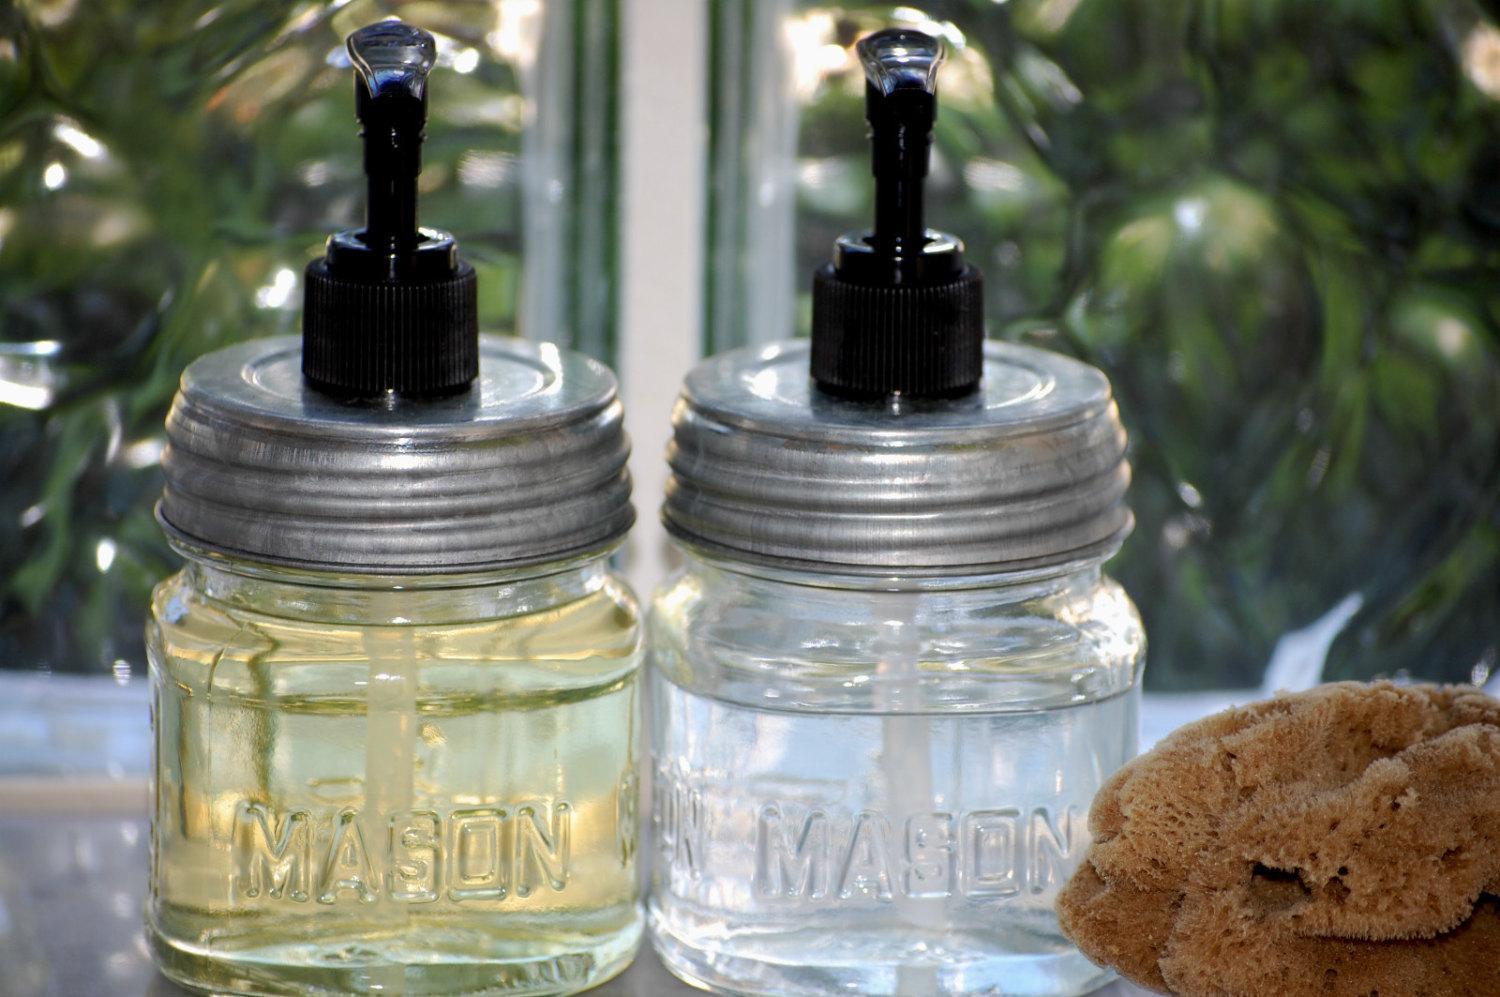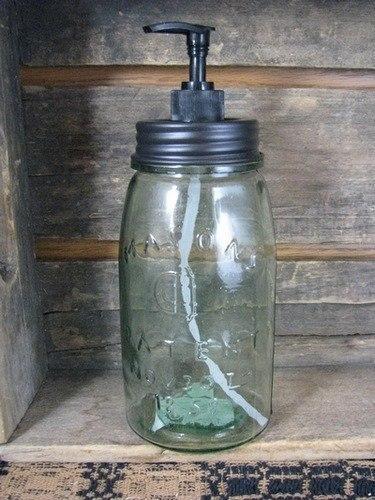The first image is the image on the left, the second image is the image on the right. For the images shown, is this caption "There are no less three bottles in the pair of images." true? Answer yes or no. Yes. 